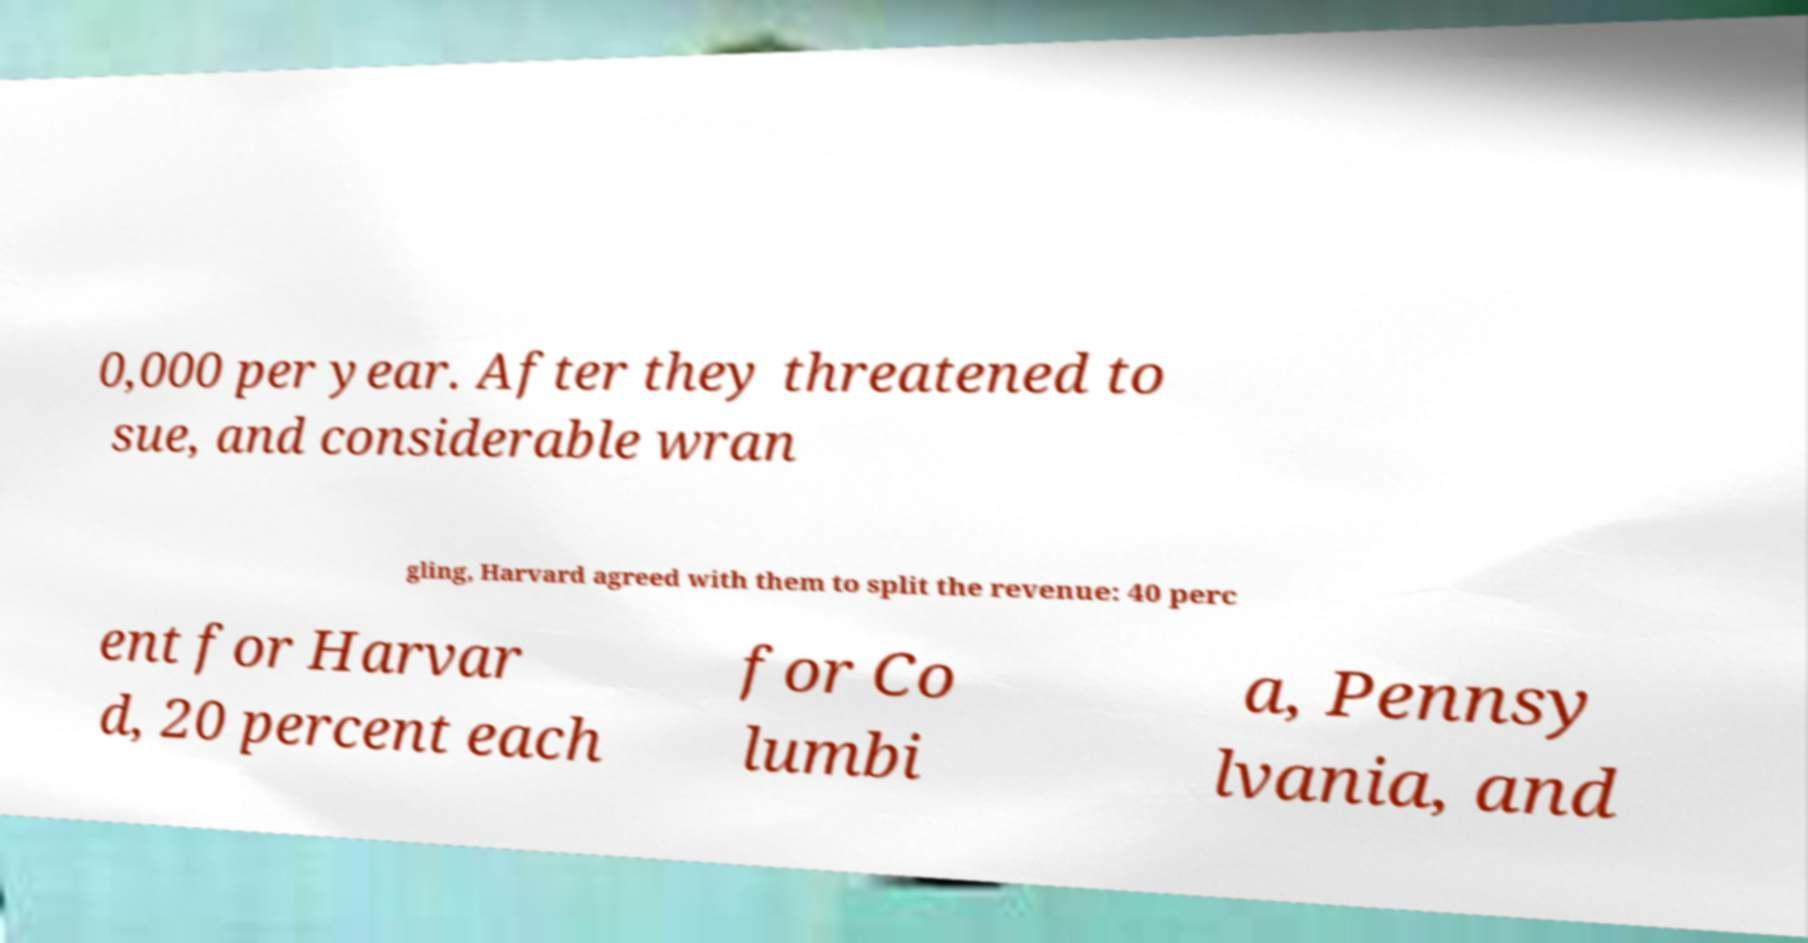Could you extract and type out the text from this image? 0,000 per year. After they threatened to sue, and considerable wran gling, Harvard agreed with them to split the revenue: 40 perc ent for Harvar d, 20 percent each for Co lumbi a, Pennsy lvania, and 